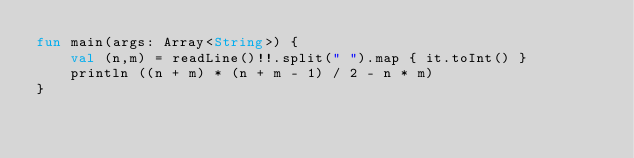Convert code to text. <code><loc_0><loc_0><loc_500><loc_500><_Kotlin_>fun main(args: Array<String>) {
    val (n,m) = readLine()!!.split(" ").map { it.toInt() }
    println ((n + m) * (n + m - 1) / 2 - n * m)
}</code> 